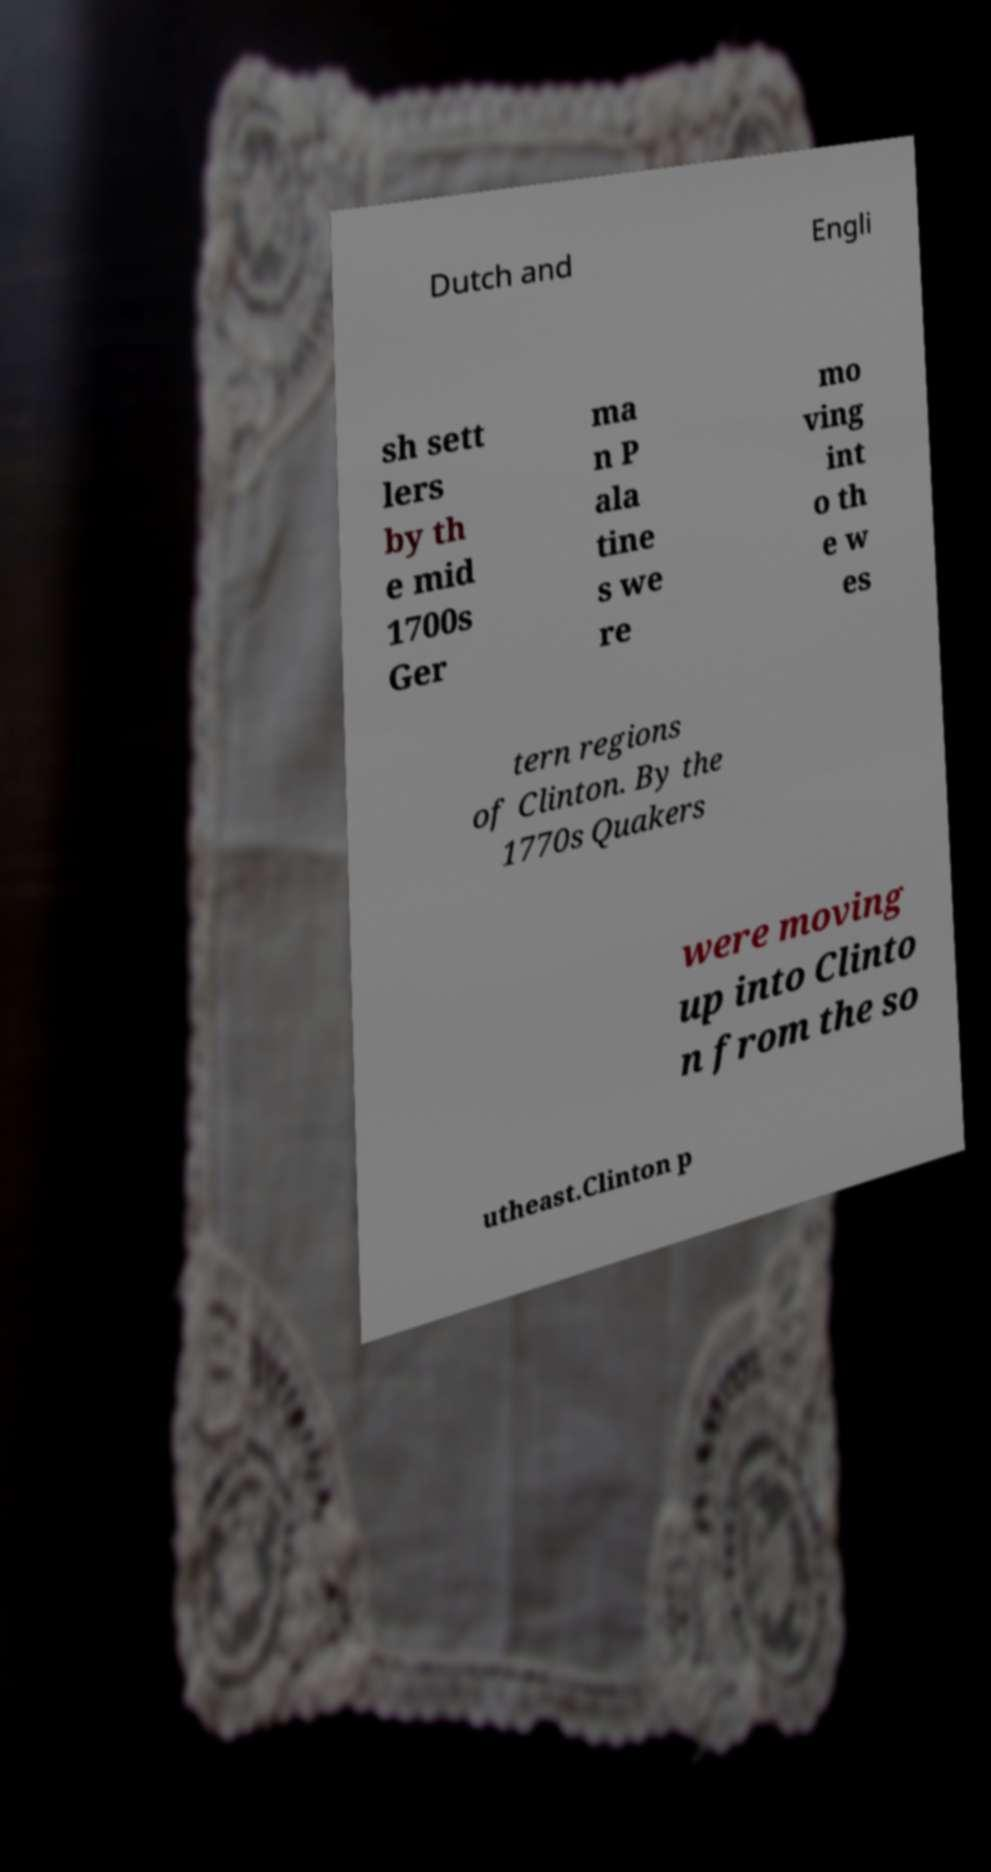Could you extract and type out the text from this image? Dutch and Engli sh sett lers by th e mid 1700s Ger ma n P ala tine s we re mo ving int o th e w es tern regions of Clinton. By the 1770s Quakers were moving up into Clinto n from the so utheast.Clinton p 